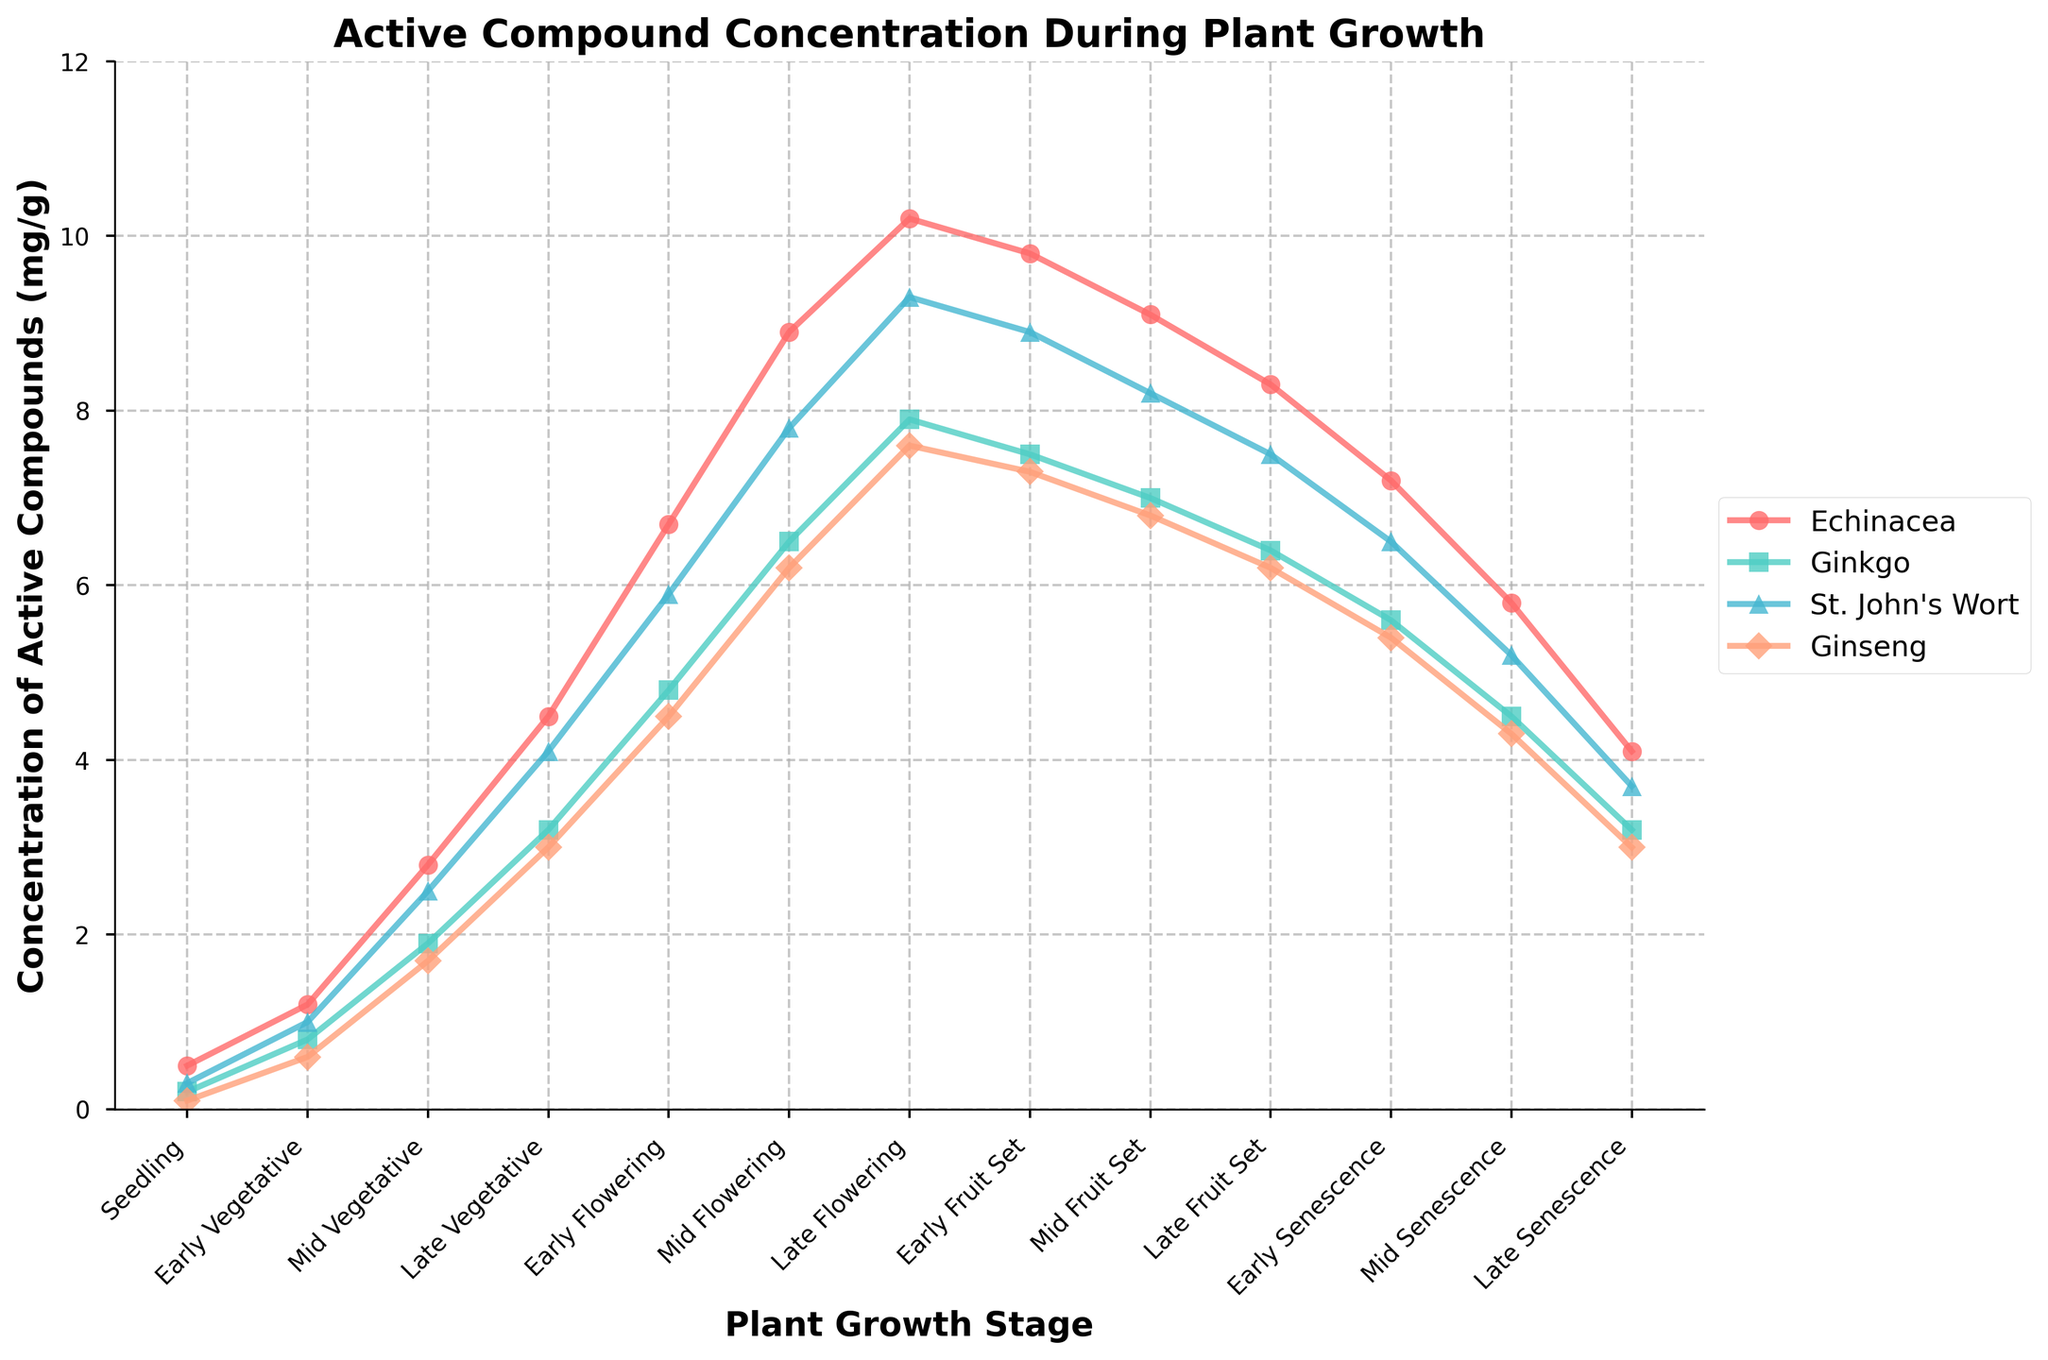What is the highest concentration of active compounds reached for St. John's Wort? From the line chart, we can observe the peak value for St. John's Wort on the y-axis. The highest concentration occurs during the Late Flowering stage, reaching 9.3 mg/g.
Answer: 9.3 mg/g Compare the concentrations of Echinacea and Ginseng at the Mid Vegetative stage. Which one is higher? At the Mid Vegetative stage, Echinacea has a concentration of 2.8 mg/g while Ginseng has 1.7 mg/g. Since 2.8 is greater than 1.7, Echinacea has the higher concentration.
Answer: Echinacea What is the average concentration of Ginkgo from Early Vegetative to Mid Flowering stages? The concentrations of Ginkgo during these stages are 0.8, 1.9, 3.2, 4.8, and 6.5 mg/g. Summing these values: 0.8 + 1.9 + 3.2 + 4.8 + 6.5 = 17.2. There are 5 stages, so the average is 17.2 / 5 = 3.44 mg/g.
Answer: 3.44 mg/g Which plant shows the most significant increase in concentration between Early Vegetative and Mid Flowering stages? Echinacea increases from 1.2 to 8.9 (7.7 increase), Ginkgo from 0.8 to 6.5 (5.7 increase), St. John's Wort from 1.0 to 7.8 (6.8 increase), and Ginseng from 0.6 to 6.2 (5.6 increase). The most significant increase is for Echinacea (7.7 mg/g).
Answer: Echinacea At which stage do all plants have the lowest concentrations of active compounds? Observing the entire x-axis, the stage where all plants have their minimum values is the Seedling stage, where Echinacea is at 0.5, Ginkgo at 0.2, St. John's Wort at 0.3, and Ginseng at 0.1 mg/g.
Answer: Seedling What is the total concentration of active compounds for Echinacea during the Flowering stages (Early, Mid, Late)? Summing the concentrations during these stages for Echinacea: 6.7 + 8.9 + 10.2 = 25.8 mg/g.
Answer: 25.8 mg/g How do the Ginkgo concentrations change from Late Flowering to Late Senescence stages? From Late Flowering to Late Senescence, the concentrations in order are: 7.9, 7.5, 7.0, 6.4, 5.6, 4.5, and 3.2 mg/g. The concentrations decrease steadily through each stage.
Answer: Steadily decrease What's the difference between the maximum concentration of Echinacea and the maximum concentration of Ginseng? The maximum concentration of Echinacea is 10.2 mg/g and for Ginseng, it is 7.6 mg/g. The difference is calculated as 10.2 - 7.6 = 2.6 mg/g.
Answer: 2.6 mg/g Which stage exhibits the smallest difference between the concentrations of Echinacea and St. John's Wort? Subtract the St. John's Wort values from Echinacea for each stage and find the smallest difference: 0.5-0.3=0.2, 1.2-1.0=0.2, 2.8-2.5=0.3, and so on. The smallest differences occur at the Seedling and Early Vegetative stages, both with 0.2 mg/g.
Answer: Seedling and Early Vegetative 